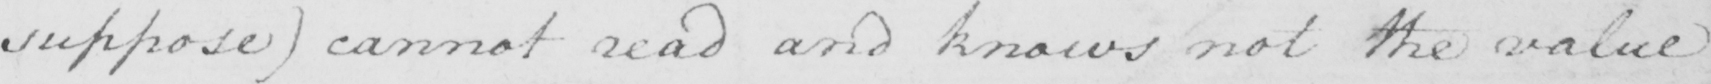What is written in this line of handwriting? suppose )  canot read and knows not the value 